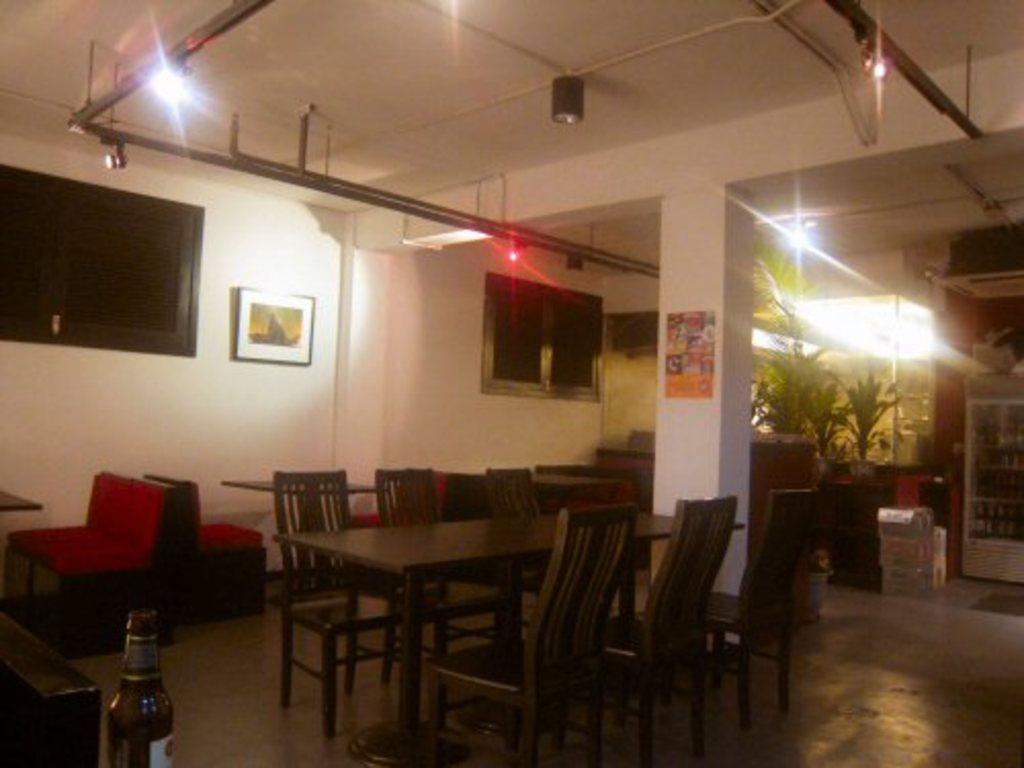Can you describe this image briefly? Here we can see a dining table and chairs on the floor, and at side here is the pillar, and here is the wall and photo frame son it,and here is the window, and here are the trees, and at above here are the lights. 